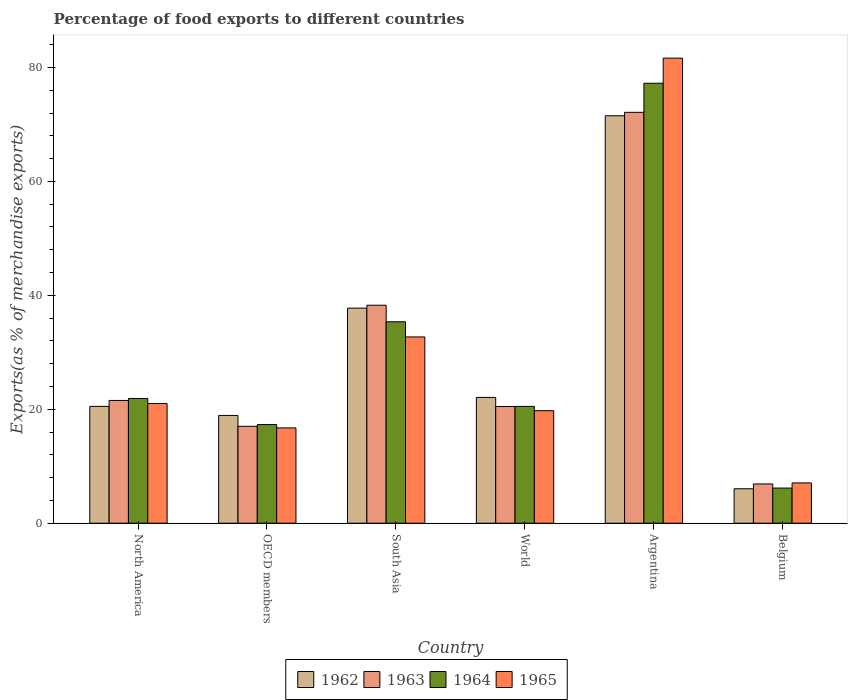How many different coloured bars are there?
Your response must be concise. 4. Are the number of bars on each tick of the X-axis equal?
Your response must be concise. Yes. What is the percentage of exports to different countries in 1963 in OECD members?
Your answer should be very brief. 17.01. Across all countries, what is the maximum percentage of exports to different countries in 1965?
Offer a terse response. 81.64. Across all countries, what is the minimum percentage of exports to different countries in 1962?
Provide a succinct answer. 6.04. What is the total percentage of exports to different countries in 1965 in the graph?
Your answer should be compact. 178.89. What is the difference between the percentage of exports to different countries in 1963 in North America and that in South Asia?
Give a very brief answer. -16.72. What is the difference between the percentage of exports to different countries in 1965 in Belgium and the percentage of exports to different countries in 1963 in South Asia?
Give a very brief answer. -31.19. What is the average percentage of exports to different countries in 1964 per country?
Provide a short and direct response. 29.75. What is the difference between the percentage of exports to different countries of/in 1962 and percentage of exports to different countries of/in 1964 in Argentina?
Provide a succinct answer. -5.71. What is the ratio of the percentage of exports to different countries in 1962 in Belgium to that in World?
Provide a succinct answer. 0.27. Is the percentage of exports to different countries in 1963 in Belgium less than that in South Asia?
Your response must be concise. Yes. What is the difference between the highest and the second highest percentage of exports to different countries in 1964?
Offer a terse response. -13.46. What is the difference between the highest and the lowest percentage of exports to different countries in 1962?
Your answer should be compact. 65.47. What does the 4th bar from the left in Argentina represents?
Offer a very short reply. 1965. What does the 4th bar from the right in South Asia represents?
Provide a short and direct response. 1962. How many bars are there?
Keep it short and to the point. 24. What is the difference between two consecutive major ticks on the Y-axis?
Give a very brief answer. 20. Are the values on the major ticks of Y-axis written in scientific E-notation?
Ensure brevity in your answer.  No. Where does the legend appear in the graph?
Ensure brevity in your answer.  Bottom center. How many legend labels are there?
Your response must be concise. 4. How are the legend labels stacked?
Your answer should be compact. Horizontal. What is the title of the graph?
Your answer should be compact. Percentage of food exports to different countries. What is the label or title of the X-axis?
Ensure brevity in your answer.  Country. What is the label or title of the Y-axis?
Provide a short and direct response. Exports(as % of merchandise exports). What is the Exports(as % of merchandise exports) of 1962 in North America?
Keep it short and to the point. 20.51. What is the Exports(as % of merchandise exports) in 1963 in North America?
Ensure brevity in your answer.  21.55. What is the Exports(as % of merchandise exports) in 1964 in North America?
Offer a terse response. 21.9. What is the Exports(as % of merchandise exports) in 1965 in North America?
Keep it short and to the point. 21.01. What is the Exports(as % of merchandise exports) of 1962 in OECD members?
Offer a terse response. 18.92. What is the Exports(as % of merchandise exports) in 1963 in OECD members?
Ensure brevity in your answer.  17.01. What is the Exports(as % of merchandise exports) of 1964 in OECD members?
Provide a succinct answer. 17.31. What is the Exports(as % of merchandise exports) of 1965 in OECD members?
Keep it short and to the point. 16.73. What is the Exports(as % of merchandise exports) of 1962 in South Asia?
Provide a succinct answer. 37.75. What is the Exports(as % of merchandise exports) in 1963 in South Asia?
Ensure brevity in your answer.  38.26. What is the Exports(as % of merchandise exports) in 1964 in South Asia?
Give a very brief answer. 35.36. What is the Exports(as % of merchandise exports) of 1965 in South Asia?
Give a very brief answer. 32.7. What is the Exports(as % of merchandise exports) of 1962 in World?
Give a very brief answer. 22.08. What is the Exports(as % of merchandise exports) of 1963 in World?
Make the answer very short. 20.49. What is the Exports(as % of merchandise exports) in 1964 in World?
Offer a terse response. 20.5. What is the Exports(as % of merchandise exports) of 1965 in World?
Offer a very short reply. 19.75. What is the Exports(as % of merchandise exports) in 1962 in Argentina?
Offer a terse response. 71.52. What is the Exports(as % of merchandise exports) in 1963 in Argentina?
Keep it short and to the point. 72.12. What is the Exports(as % of merchandise exports) in 1964 in Argentina?
Provide a short and direct response. 77.23. What is the Exports(as % of merchandise exports) in 1965 in Argentina?
Your response must be concise. 81.64. What is the Exports(as % of merchandise exports) in 1962 in Belgium?
Your response must be concise. 6.04. What is the Exports(as % of merchandise exports) in 1963 in Belgium?
Provide a short and direct response. 6.89. What is the Exports(as % of merchandise exports) of 1964 in Belgium?
Provide a short and direct response. 6.17. What is the Exports(as % of merchandise exports) of 1965 in Belgium?
Give a very brief answer. 7.07. Across all countries, what is the maximum Exports(as % of merchandise exports) in 1962?
Offer a very short reply. 71.52. Across all countries, what is the maximum Exports(as % of merchandise exports) of 1963?
Give a very brief answer. 72.12. Across all countries, what is the maximum Exports(as % of merchandise exports) of 1964?
Keep it short and to the point. 77.23. Across all countries, what is the maximum Exports(as % of merchandise exports) in 1965?
Offer a terse response. 81.64. Across all countries, what is the minimum Exports(as % of merchandise exports) in 1962?
Give a very brief answer. 6.04. Across all countries, what is the minimum Exports(as % of merchandise exports) in 1963?
Give a very brief answer. 6.89. Across all countries, what is the minimum Exports(as % of merchandise exports) in 1964?
Keep it short and to the point. 6.17. Across all countries, what is the minimum Exports(as % of merchandise exports) of 1965?
Keep it short and to the point. 7.07. What is the total Exports(as % of merchandise exports) in 1962 in the graph?
Your answer should be compact. 176.82. What is the total Exports(as % of merchandise exports) of 1963 in the graph?
Make the answer very short. 176.32. What is the total Exports(as % of merchandise exports) in 1964 in the graph?
Make the answer very short. 178.47. What is the total Exports(as % of merchandise exports) in 1965 in the graph?
Make the answer very short. 178.89. What is the difference between the Exports(as % of merchandise exports) in 1962 in North America and that in OECD members?
Make the answer very short. 1.59. What is the difference between the Exports(as % of merchandise exports) in 1963 in North America and that in OECD members?
Your answer should be compact. 4.54. What is the difference between the Exports(as % of merchandise exports) in 1964 in North America and that in OECD members?
Offer a very short reply. 4.58. What is the difference between the Exports(as % of merchandise exports) of 1965 in North America and that in OECD members?
Your answer should be compact. 4.28. What is the difference between the Exports(as % of merchandise exports) in 1962 in North America and that in South Asia?
Make the answer very short. -17.25. What is the difference between the Exports(as % of merchandise exports) in 1963 in North America and that in South Asia?
Keep it short and to the point. -16.72. What is the difference between the Exports(as % of merchandise exports) of 1964 in North America and that in South Asia?
Your answer should be compact. -13.46. What is the difference between the Exports(as % of merchandise exports) in 1965 in North America and that in South Asia?
Provide a succinct answer. -11.69. What is the difference between the Exports(as % of merchandise exports) of 1962 in North America and that in World?
Provide a succinct answer. -1.57. What is the difference between the Exports(as % of merchandise exports) in 1963 in North America and that in World?
Ensure brevity in your answer.  1.06. What is the difference between the Exports(as % of merchandise exports) in 1964 in North America and that in World?
Provide a short and direct response. 1.39. What is the difference between the Exports(as % of merchandise exports) in 1965 in North America and that in World?
Your answer should be compact. 1.26. What is the difference between the Exports(as % of merchandise exports) of 1962 in North America and that in Argentina?
Give a very brief answer. -51.01. What is the difference between the Exports(as % of merchandise exports) of 1963 in North America and that in Argentina?
Ensure brevity in your answer.  -50.58. What is the difference between the Exports(as % of merchandise exports) in 1964 in North America and that in Argentina?
Provide a short and direct response. -55.33. What is the difference between the Exports(as % of merchandise exports) of 1965 in North America and that in Argentina?
Keep it short and to the point. -60.63. What is the difference between the Exports(as % of merchandise exports) of 1962 in North America and that in Belgium?
Keep it short and to the point. 14.47. What is the difference between the Exports(as % of merchandise exports) of 1963 in North America and that in Belgium?
Make the answer very short. 14.66. What is the difference between the Exports(as % of merchandise exports) of 1964 in North America and that in Belgium?
Your response must be concise. 15.73. What is the difference between the Exports(as % of merchandise exports) in 1965 in North America and that in Belgium?
Your answer should be compact. 13.93. What is the difference between the Exports(as % of merchandise exports) of 1962 in OECD members and that in South Asia?
Keep it short and to the point. -18.84. What is the difference between the Exports(as % of merchandise exports) in 1963 in OECD members and that in South Asia?
Give a very brief answer. -21.26. What is the difference between the Exports(as % of merchandise exports) of 1964 in OECD members and that in South Asia?
Your response must be concise. -18.05. What is the difference between the Exports(as % of merchandise exports) of 1965 in OECD members and that in South Asia?
Provide a succinct answer. -15.97. What is the difference between the Exports(as % of merchandise exports) in 1962 in OECD members and that in World?
Your response must be concise. -3.16. What is the difference between the Exports(as % of merchandise exports) of 1963 in OECD members and that in World?
Make the answer very short. -3.48. What is the difference between the Exports(as % of merchandise exports) in 1964 in OECD members and that in World?
Make the answer very short. -3.19. What is the difference between the Exports(as % of merchandise exports) of 1965 in OECD members and that in World?
Offer a very short reply. -3.02. What is the difference between the Exports(as % of merchandise exports) in 1962 in OECD members and that in Argentina?
Your answer should be very brief. -52.6. What is the difference between the Exports(as % of merchandise exports) of 1963 in OECD members and that in Argentina?
Offer a terse response. -55.12. What is the difference between the Exports(as % of merchandise exports) of 1964 in OECD members and that in Argentina?
Your response must be concise. -59.91. What is the difference between the Exports(as % of merchandise exports) in 1965 in OECD members and that in Argentina?
Keep it short and to the point. -64.91. What is the difference between the Exports(as % of merchandise exports) of 1962 in OECD members and that in Belgium?
Provide a succinct answer. 12.87. What is the difference between the Exports(as % of merchandise exports) of 1963 in OECD members and that in Belgium?
Keep it short and to the point. 10.12. What is the difference between the Exports(as % of merchandise exports) of 1964 in OECD members and that in Belgium?
Offer a very short reply. 11.14. What is the difference between the Exports(as % of merchandise exports) in 1965 in OECD members and that in Belgium?
Provide a succinct answer. 9.66. What is the difference between the Exports(as % of merchandise exports) in 1962 in South Asia and that in World?
Make the answer very short. 15.67. What is the difference between the Exports(as % of merchandise exports) of 1963 in South Asia and that in World?
Your answer should be compact. 17.78. What is the difference between the Exports(as % of merchandise exports) of 1964 in South Asia and that in World?
Provide a short and direct response. 14.86. What is the difference between the Exports(as % of merchandise exports) in 1965 in South Asia and that in World?
Your response must be concise. 12.95. What is the difference between the Exports(as % of merchandise exports) of 1962 in South Asia and that in Argentina?
Your answer should be compact. -33.76. What is the difference between the Exports(as % of merchandise exports) in 1963 in South Asia and that in Argentina?
Your response must be concise. -33.86. What is the difference between the Exports(as % of merchandise exports) in 1964 in South Asia and that in Argentina?
Keep it short and to the point. -41.87. What is the difference between the Exports(as % of merchandise exports) in 1965 in South Asia and that in Argentina?
Make the answer very short. -48.94. What is the difference between the Exports(as % of merchandise exports) in 1962 in South Asia and that in Belgium?
Offer a terse response. 31.71. What is the difference between the Exports(as % of merchandise exports) of 1963 in South Asia and that in Belgium?
Keep it short and to the point. 31.37. What is the difference between the Exports(as % of merchandise exports) of 1964 in South Asia and that in Belgium?
Provide a short and direct response. 29.19. What is the difference between the Exports(as % of merchandise exports) in 1965 in South Asia and that in Belgium?
Your answer should be compact. 25.62. What is the difference between the Exports(as % of merchandise exports) of 1962 in World and that in Argentina?
Ensure brevity in your answer.  -49.44. What is the difference between the Exports(as % of merchandise exports) of 1963 in World and that in Argentina?
Give a very brief answer. -51.64. What is the difference between the Exports(as % of merchandise exports) of 1964 in World and that in Argentina?
Offer a very short reply. -56.72. What is the difference between the Exports(as % of merchandise exports) in 1965 in World and that in Argentina?
Offer a very short reply. -61.88. What is the difference between the Exports(as % of merchandise exports) of 1962 in World and that in Belgium?
Provide a short and direct response. 16.04. What is the difference between the Exports(as % of merchandise exports) of 1963 in World and that in Belgium?
Give a very brief answer. 13.6. What is the difference between the Exports(as % of merchandise exports) of 1964 in World and that in Belgium?
Provide a succinct answer. 14.33. What is the difference between the Exports(as % of merchandise exports) in 1965 in World and that in Belgium?
Provide a short and direct response. 12.68. What is the difference between the Exports(as % of merchandise exports) in 1962 in Argentina and that in Belgium?
Your response must be concise. 65.47. What is the difference between the Exports(as % of merchandise exports) of 1963 in Argentina and that in Belgium?
Provide a short and direct response. 65.23. What is the difference between the Exports(as % of merchandise exports) in 1964 in Argentina and that in Belgium?
Offer a terse response. 71.06. What is the difference between the Exports(as % of merchandise exports) in 1965 in Argentina and that in Belgium?
Give a very brief answer. 74.56. What is the difference between the Exports(as % of merchandise exports) of 1962 in North America and the Exports(as % of merchandise exports) of 1963 in OECD members?
Your answer should be very brief. 3.5. What is the difference between the Exports(as % of merchandise exports) of 1962 in North America and the Exports(as % of merchandise exports) of 1964 in OECD members?
Ensure brevity in your answer.  3.19. What is the difference between the Exports(as % of merchandise exports) of 1962 in North America and the Exports(as % of merchandise exports) of 1965 in OECD members?
Keep it short and to the point. 3.78. What is the difference between the Exports(as % of merchandise exports) of 1963 in North America and the Exports(as % of merchandise exports) of 1964 in OECD members?
Provide a succinct answer. 4.23. What is the difference between the Exports(as % of merchandise exports) of 1963 in North America and the Exports(as % of merchandise exports) of 1965 in OECD members?
Provide a succinct answer. 4.82. What is the difference between the Exports(as % of merchandise exports) in 1964 in North America and the Exports(as % of merchandise exports) in 1965 in OECD members?
Provide a succinct answer. 5.17. What is the difference between the Exports(as % of merchandise exports) of 1962 in North America and the Exports(as % of merchandise exports) of 1963 in South Asia?
Your answer should be compact. -17.76. What is the difference between the Exports(as % of merchandise exports) in 1962 in North America and the Exports(as % of merchandise exports) in 1964 in South Asia?
Provide a short and direct response. -14.85. What is the difference between the Exports(as % of merchandise exports) of 1962 in North America and the Exports(as % of merchandise exports) of 1965 in South Asia?
Offer a terse response. -12.19. What is the difference between the Exports(as % of merchandise exports) in 1963 in North America and the Exports(as % of merchandise exports) in 1964 in South Asia?
Offer a terse response. -13.81. What is the difference between the Exports(as % of merchandise exports) in 1963 in North America and the Exports(as % of merchandise exports) in 1965 in South Asia?
Your answer should be very brief. -11.15. What is the difference between the Exports(as % of merchandise exports) of 1964 in North America and the Exports(as % of merchandise exports) of 1965 in South Asia?
Give a very brief answer. -10.8. What is the difference between the Exports(as % of merchandise exports) of 1962 in North America and the Exports(as % of merchandise exports) of 1963 in World?
Offer a very short reply. 0.02. What is the difference between the Exports(as % of merchandise exports) in 1962 in North America and the Exports(as % of merchandise exports) in 1964 in World?
Offer a terse response. 0.01. What is the difference between the Exports(as % of merchandise exports) in 1962 in North America and the Exports(as % of merchandise exports) in 1965 in World?
Your answer should be very brief. 0.76. What is the difference between the Exports(as % of merchandise exports) in 1963 in North America and the Exports(as % of merchandise exports) in 1964 in World?
Offer a very short reply. 1.04. What is the difference between the Exports(as % of merchandise exports) in 1963 in North America and the Exports(as % of merchandise exports) in 1965 in World?
Keep it short and to the point. 1.8. What is the difference between the Exports(as % of merchandise exports) in 1964 in North America and the Exports(as % of merchandise exports) in 1965 in World?
Make the answer very short. 2.15. What is the difference between the Exports(as % of merchandise exports) in 1962 in North America and the Exports(as % of merchandise exports) in 1963 in Argentina?
Give a very brief answer. -51.62. What is the difference between the Exports(as % of merchandise exports) in 1962 in North America and the Exports(as % of merchandise exports) in 1964 in Argentina?
Your answer should be compact. -56.72. What is the difference between the Exports(as % of merchandise exports) in 1962 in North America and the Exports(as % of merchandise exports) in 1965 in Argentina?
Provide a succinct answer. -61.13. What is the difference between the Exports(as % of merchandise exports) in 1963 in North America and the Exports(as % of merchandise exports) in 1964 in Argentina?
Offer a terse response. -55.68. What is the difference between the Exports(as % of merchandise exports) of 1963 in North America and the Exports(as % of merchandise exports) of 1965 in Argentina?
Make the answer very short. -60.09. What is the difference between the Exports(as % of merchandise exports) in 1964 in North America and the Exports(as % of merchandise exports) in 1965 in Argentina?
Your answer should be very brief. -59.74. What is the difference between the Exports(as % of merchandise exports) in 1962 in North America and the Exports(as % of merchandise exports) in 1963 in Belgium?
Keep it short and to the point. 13.62. What is the difference between the Exports(as % of merchandise exports) of 1962 in North America and the Exports(as % of merchandise exports) of 1964 in Belgium?
Your answer should be compact. 14.34. What is the difference between the Exports(as % of merchandise exports) of 1962 in North America and the Exports(as % of merchandise exports) of 1965 in Belgium?
Your answer should be compact. 13.44. What is the difference between the Exports(as % of merchandise exports) in 1963 in North America and the Exports(as % of merchandise exports) in 1964 in Belgium?
Provide a succinct answer. 15.38. What is the difference between the Exports(as % of merchandise exports) in 1963 in North America and the Exports(as % of merchandise exports) in 1965 in Belgium?
Provide a short and direct response. 14.48. What is the difference between the Exports(as % of merchandise exports) of 1964 in North America and the Exports(as % of merchandise exports) of 1965 in Belgium?
Your response must be concise. 14.82. What is the difference between the Exports(as % of merchandise exports) of 1962 in OECD members and the Exports(as % of merchandise exports) of 1963 in South Asia?
Ensure brevity in your answer.  -19.35. What is the difference between the Exports(as % of merchandise exports) of 1962 in OECD members and the Exports(as % of merchandise exports) of 1964 in South Asia?
Your response must be concise. -16.44. What is the difference between the Exports(as % of merchandise exports) in 1962 in OECD members and the Exports(as % of merchandise exports) in 1965 in South Asia?
Ensure brevity in your answer.  -13.78. What is the difference between the Exports(as % of merchandise exports) in 1963 in OECD members and the Exports(as % of merchandise exports) in 1964 in South Asia?
Provide a short and direct response. -18.35. What is the difference between the Exports(as % of merchandise exports) of 1963 in OECD members and the Exports(as % of merchandise exports) of 1965 in South Asia?
Your answer should be compact. -15.69. What is the difference between the Exports(as % of merchandise exports) of 1964 in OECD members and the Exports(as % of merchandise exports) of 1965 in South Asia?
Ensure brevity in your answer.  -15.38. What is the difference between the Exports(as % of merchandise exports) in 1962 in OECD members and the Exports(as % of merchandise exports) in 1963 in World?
Provide a short and direct response. -1.57. What is the difference between the Exports(as % of merchandise exports) in 1962 in OECD members and the Exports(as % of merchandise exports) in 1964 in World?
Your answer should be compact. -1.59. What is the difference between the Exports(as % of merchandise exports) in 1962 in OECD members and the Exports(as % of merchandise exports) in 1965 in World?
Ensure brevity in your answer.  -0.83. What is the difference between the Exports(as % of merchandise exports) of 1963 in OECD members and the Exports(as % of merchandise exports) of 1964 in World?
Provide a succinct answer. -3.5. What is the difference between the Exports(as % of merchandise exports) in 1963 in OECD members and the Exports(as % of merchandise exports) in 1965 in World?
Your answer should be compact. -2.74. What is the difference between the Exports(as % of merchandise exports) of 1964 in OECD members and the Exports(as % of merchandise exports) of 1965 in World?
Give a very brief answer. -2.44. What is the difference between the Exports(as % of merchandise exports) of 1962 in OECD members and the Exports(as % of merchandise exports) of 1963 in Argentina?
Provide a succinct answer. -53.21. What is the difference between the Exports(as % of merchandise exports) in 1962 in OECD members and the Exports(as % of merchandise exports) in 1964 in Argentina?
Your answer should be very brief. -58.31. What is the difference between the Exports(as % of merchandise exports) of 1962 in OECD members and the Exports(as % of merchandise exports) of 1965 in Argentina?
Offer a very short reply. -62.72. What is the difference between the Exports(as % of merchandise exports) of 1963 in OECD members and the Exports(as % of merchandise exports) of 1964 in Argentina?
Your answer should be very brief. -60.22. What is the difference between the Exports(as % of merchandise exports) of 1963 in OECD members and the Exports(as % of merchandise exports) of 1965 in Argentina?
Give a very brief answer. -64.63. What is the difference between the Exports(as % of merchandise exports) in 1964 in OECD members and the Exports(as % of merchandise exports) in 1965 in Argentina?
Provide a short and direct response. -64.32. What is the difference between the Exports(as % of merchandise exports) of 1962 in OECD members and the Exports(as % of merchandise exports) of 1963 in Belgium?
Provide a short and direct response. 12.03. What is the difference between the Exports(as % of merchandise exports) of 1962 in OECD members and the Exports(as % of merchandise exports) of 1964 in Belgium?
Offer a very short reply. 12.75. What is the difference between the Exports(as % of merchandise exports) of 1962 in OECD members and the Exports(as % of merchandise exports) of 1965 in Belgium?
Ensure brevity in your answer.  11.84. What is the difference between the Exports(as % of merchandise exports) of 1963 in OECD members and the Exports(as % of merchandise exports) of 1964 in Belgium?
Offer a very short reply. 10.84. What is the difference between the Exports(as % of merchandise exports) of 1963 in OECD members and the Exports(as % of merchandise exports) of 1965 in Belgium?
Ensure brevity in your answer.  9.93. What is the difference between the Exports(as % of merchandise exports) in 1964 in OECD members and the Exports(as % of merchandise exports) in 1965 in Belgium?
Make the answer very short. 10.24. What is the difference between the Exports(as % of merchandise exports) in 1962 in South Asia and the Exports(as % of merchandise exports) in 1963 in World?
Offer a very short reply. 17.27. What is the difference between the Exports(as % of merchandise exports) of 1962 in South Asia and the Exports(as % of merchandise exports) of 1964 in World?
Ensure brevity in your answer.  17.25. What is the difference between the Exports(as % of merchandise exports) of 1962 in South Asia and the Exports(as % of merchandise exports) of 1965 in World?
Make the answer very short. 18. What is the difference between the Exports(as % of merchandise exports) in 1963 in South Asia and the Exports(as % of merchandise exports) in 1964 in World?
Ensure brevity in your answer.  17.76. What is the difference between the Exports(as % of merchandise exports) of 1963 in South Asia and the Exports(as % of merchandise exports) of 1965 in World?
Offer a terse response. 18.51. What is the difference between the Exports(as % of merchandise exports) in 1964 in South Asia and the Exports(as % of merchandise exports) in 1965 in World?
Keep it short and to the point. 15.61. What is the difference between the Exports(as % of merchandise exports) of 1962 in South Asia and the Exports(as % of merchandise exports) of 1963 in Argentina?
Provide a succinct answer. -34.37. What is the difference between the Exports(as % of merchandise exports) of 1962 in South Asia and the Exports(as % of merchandise exports) of 1964 in Argentina?
Ensure brevity in your answer.  -39.47. What is the difference between the Exports(as % of merchandise exports) of 1962 in South Asia and the Exports(as % of merchandise exports) of 1965 in Argentina?
Provide a succinct answer. -43.88. What is the difference between the Exports(as % of merchandise exports) in 1963 in South Asia and the Exports(as % of merchandise exports) in 1964 in Argentina?
Offer a very short reply. -38.96. What is the difference between the Exports(as % of merchandise exports) in 1963 in South Asia and the Exports(as % of merchandise exports) in 1965 in Argentina?
Keep it short and to the point. -43.37. What is the difference between the Exports(as % of merchandise exports) in 1964 in South Asia and the Exports(as % of merchandise exports) in 1965 in Argentina?
Offer a very short reply. -46.28. What is the difference between the Exports(as % of merchandise exports) in 1962 in South Asia and the Exports(as % of merchandise exports) in 1963 in Belgium?
Your response must be concise. 30.86. What is the difference between the Exports(as % of merchandise exports) in 1962 in South Asia and the Exports(as % of merchandise exports) in 1964 in Belgium?
Offer a terse response. 31.58. What is the difference between the Exports(as % of merchandise exports) in 1962 in South Asia and the Exports(as % of merchandise exports) in 1965 in Belgium?
Your response must be concise. 30.68. What is the difference between the Exports(as % of merchandise exports) of 1963 in South Asia and the Exports(as % of merchandise exports) of 1964 in Belgium?
Provide a short and direct response. 32.09. What is the difference between the Exports(as % of merchandise exports) of 1963 in South Asia and the Exports(as % of merchandise exports) of 1965 in Belgium?
Provide a succinct answer. 31.19. What is the difference between the Exports(as % of merchandise exports) of 1964 in South Asia and the Exports(as % of merchandise exports) of 1965 in Belgium?
Ensure brevity in your answer.  28.29. What is the difference between the Exports(as % of merchandise exports) in 1962 in World and the Exports(as % of merchandise exports) in 1963 in Argentina?
Make the answer very short. -50.04. What is the difference between the Exports(as % of merchandise exports) in 1962 in World and the Exports(as % of merchandise exports) in 1964 in Argentina?
Give a very brief answer. -55.15. What is the difference between the Exports(as % of merchandise exports) of 1962 in World and the Exports(as % of merchandise exports) of 1965 in Argentina?
Keep it short and to the point. -59.55. What is the difference between the Exports(as % of merchandise exports) of 1963 in World and the Exports(as % of merchandise exports) of 1964 in Argentina?
Your answer should be very brief. -56.74. What is the difference between the Exports(as % of merchandise exports) in 1963 in World and the Exports(as % of merchandise exports) in 1965 in Argentina?
Provide a succinct answer. -61.15. What is the difference between the Exports(as % of merchandise exports) in 1964 in World and the Exports(as % of merchandise exports) in 1965 in Argentina?
Keep it short and to the point. -61.13. What is the difference between the Exports(as % of merchandise exports) in 1962 in World and the Exports(as % of merchandise exports) in 1963 in Belgium?
Ensure brevity in your answer.  15.19. What is the difference between the Exports(as % of merchandise exports) of 1962 in World and the Exports(as % of merchandise exports) of 1964 in Belgium?
Offer a terse response. 15.91. What is the difference between the Exports(as % of merchandise exports) of 1962 in World and the Exports(as % of merchandise exports) of 1965 in Belgium?
Give a very brief answer. 15.01. What is the difference between the Exports(as % of merchandise exports) of 1963 in World and the Exports(as % of merchandise exports) of 1964 in Belgium?
Your answer should be compact. 14.32. What is the difference between the Exports(as % of merchandise exports) of 1963 in World and the Exports(as % of merchandise exports) of 1965 in Belgium?
Keep it short and to the point. 13.41. What is the difference between the Exports(as % of merchandise exports) in 1964 in World and the Exports(as % of merchandise exports) in 1965 in Belgium?
Make the answer very short. 13.43. What is the difference between the Exports(as % of merchandise exports) in 1962 in Argentina and the Exports(as % of merchandise exports) in 1963 in Belgium?
Offer a very short reply. 64.63. What is the difference between the Exports(as % of merchandise exports) of 1962 in Argentina and the Exports(as % of merchandise exports) of 1964 in Belgium?
Ensure brevity in your answer.  65.35. What is the difference between the Exports(as % of merchandise exports) in 1962 in Argentina and the Exports(as % of merchandise exports) in 1965 in Belgium?
Your answer should be very brief. 64.44. What is the difference between the Exports(as % of merchandise exports) in 1963 in Argentina and the Exports(as % of merchandise exports) in 1964 in Belgium?
Offer a very short reply. 65.95. What is the difference between the Exports(as % of merchandise exports) of 1963 in Argentina and the Exports(as % of merchandise exports) of 1965 in Belgium?
Offer a very short reply. 65.05. What is the difference between the Exports(as % of merchandise exports) of 1964 in Argentina and the Exports(as % of merchandise exports) of 1965 in Belgium?
Give a very brief answer. 70.15. What is the average Exports(as % of merchandise exports) of 1962 per country?
Give a very brief answer. 29.47. What is the average Exports(as % of merchandise exports) in 1963 per country?
Your response must be concise. 29.39. What is the average Exports(as % of merchandise exports) of 1964 per country?
Provide a short and direct response. 29.75. What is the average Exports(as % of merchandise exports) in 1965 per country?
Offer a very short reply. 29.82. What is the difference between the Exports(as % of merchandise exports) of 1962 and Exports(as % of merchandise exports) of 1963 in North America?
Provide a short and direct response. -1.04. What is the difference between the Exports(as % of merchandise exports) of 1962 and Exports(as % of merchandise exports) of 1964 in North America?
Your answer should be compact. -1.39. What is the difference between the Exports(as % of merchandise exports) in 1962 and Exports(as % of merchandise exports) in 1965 in North America?
Provide a succinct answer. -0.5. What is the difference between the Exports(as % of merchandise exports) in 1963 and Exports(as % of merchandise exports) in 1964 in North America?
Offer a terse response. -0.35. What is the difference between the Exports(as % of merchandise exports) of 1963 and Exports(as % of merchandise exports) of 1965 in North America?
Provide a short and direct response. 0.54. What is the difference between the Exports(as % of merchandise exports) in 1964 and Exports(as % of merchandise exports) in 1965 in North America?
Ensure brevity in your answer.  0.89. What is the difference between the Exports(as % of merchandise exports) in 1962 and Exports(as % of merchandise exports) in 1963 in OECD members?
Make the answer very short. 1.91. What is the difference between the Exports(as % of merchandise exports) of 1962 and Exports(as % of merchandise exports) of 1964 in OECD members?
Give a very brief answer. 1.6. What is the difference between the Exports(as % of merchandise exports) of 1962 and Exports(as % of merchandise exports) of 1965 in OECD members?
Provide a short and direct response. 2.19. What is the difference between the Exports(as % of merchandise exports) of 1963 and Exports(as % of merchandise exports) of 1964 in OECD members?
Offer a terse response. -0.31. What is the difference between the Exports(as % of merchandise exports) in 1963 and Exports(as % of merchandise exports) in 1965 in OECD members?
Your answer should be very brief. 0.28. What is the difference between the Exports(as % of merchandise exports) of 1964 and Exports(as % of merchandise exports) of 1965 in OECD members?
Give a very brief answer. 0.59. What is the difference between the Exports(as % of merchandise exports) in 1962 and Exports(as % of merchandise exports) in 1963 in South Asia?
Make the answer very short. -0.51. What is the difference between the Exports(as % of merchandise exports) in 1962 and Exports(as % of merchandise exports) in 1964 in South Asia?
Give a very brief answer. 2.39. What is the difference between the Exports(as % of merchandise exports) of 1962 and Exports(as % of merchandise exports) of 1965 in South Asia?
Your answer should be compact. 5.06. What is the difference between the Exports(as % of merchandise exports) of 1963 and Exports(as % of merchandise exports) of 1964 in South Asia?
Provide a succinct answer. 2.9. What is the difference between the Exports(as % of merchandise exports) of 1963 and Exports(as % of merchandise exports) of 1965 in South Asia?
Make the answer very short. 5.57. What is the difference between the Exports(as % of merchandise exports) in 1964 and Exports(as % of merchandise exports) in 1965 in South Asia?
Offer a very short reply. 2.66. What is the difference between the Exports(as % of merchandise exports) in 1962 and Exports(as % of merchandise exports) in 1963 in World?
Provide a succinct answer. 1.59. What is the difference between the Exports(as % of merchandise exports) of 1962 and Exports(as % of merchandise exports) of 1964 in World?
Give a very brief answer. 1.58. What is the difference between the Exports(as % of merchandise exports) in 1962 and Exports(as % of merchandise exports) in 1965 in World?
Offer a very short reply. 2.33. What is the difference between the Exports(as % of merchandise exports) in 1963 and Exports(as % of merchandise exports) in 1964 in World?
Your answer should be very brief. -0.02. What is the difference between the Exports(as % of merchandise exports) of 1963 and Exports(as % of merchandise exports) of 1965 in World?
Your response must be concise. 0.74. What is the difference between the Exports(as % of merchandise exports) of 1964 and Exports(as % of merchandise exports) of 1965 in World?
Offer a very short reply. 0.75. What is the difference between the Exports(as % of merchandise exports) in 1962 and Exports(as % of merchandise exports) in 1963 in Argentina?
Make the answer very short. -0.61. What is the difference between the Exports(as % of merchandise exports) in 1962 and Exports(as % of merchandise exports) in 1964 in Argentina?
Your response must be concise. -5.71. What is the difference between the Exports(as % of merchandise exports) of 1962 and Exports(as % of merchandise exports) of 1965 in Argentina?
Keep it short and to the point. -10.12. What is the difference between the Exports(as % of merchandise exports) in 1963 and Exports(as % of merchandise exports) in 1964 in Argentina?
Your answer should be very brief. -5.1. What is the difference between the Exports(as % of merchandise exports) in 1963 and Exports(as % of merchandise exports) in 1965 in Argentina?
Offer a very short reply. -9.51. What is the difference between the Exports(as % of merchandise exports) of 1964 and Exports(as % of merchandise exports) of 1965 in Argentina?
Your response must be concise. -4.41. What is the difference between the Exports(as % of merchandise exports) of 1962 and Exports(as % of merchandise exports) of 1963 in Belgium?
Offer a very short reply. -0.85. What is the difference between the Exports(as % of merchandise exports) in 1962 and Exports(as % of merchandise exports) in 1964 in Belgium?
Provide a short and direct response. -0.13. What is the difference between the Exports(as % of merchandise exports) in 1962 and Exports(as % of merchandise exports) in 1965 in Belgium?
Give a very brief answer. -1.03. What is the difference between the Exports(as % of merchandise exports) of 1963 and Exports(as % of merchandise exports) of 1964 in Belgium?
Give a very brief answer. 0.72. What is the difference between the Exports(as % of merchandise exports) in 1963 and Exports(as % of merchandise exports) in 1965 in Belgium?
Keep it short and to the point. -0.18. What is the difference between the Exports(as % of merchandise exports) in 1964 and Exports(as % of merchandise exports) in 1965 in Belgium?
Ensure brevity in your answer.  -0.9. What is the ratio of the Exports(as % of merchandise exports) in 1962 in North America to that in OECD members?
Your response must be concise. 1.08. What is the ratio of the Exports(as % of merchandise exports) of 1963 in North America to that in OECD members?
Ensure brevity in your answer.  1.27. What is the ratio of the Exports(as % of merchandise exports) of 1964 in North America to that in OECD members?
Give a very brief answer. 1.26. What is the ratio of the Exports(as % of merchandise exports) in 1965 in North America to that in OECD members?
Your answer should be compact. 1.26. What is the ratio of the Exports(as % of merchandise exports) of 1962 in North America to that in South Asia?
Provide a short and direct response. 0.54. What is the ratio of the Exports(as % of merchandise exports) in 1963 in North America to that in South Asia?
Make the answer very short. 0.56. What is the ratio of the Exports(as % of merchandise exports) in 1964 in North America to that in South Asia?
Keep it short and to the point. 0.62. What is the ratio of the Exports(as % of merchandise exports) in 1965 in North America to that in South Asia?
Make the answer very short. 0.64. What is the ratio of the Exports(as % of merchandise exports) in 1962 in North America to that in World?
Offer a terse response. 0.93. What is the ratio of the Exports(as % of merchandise exports) of 1963 in North America to that in World?
Your answer should be compact. 1.05. What is the ratio of the Exports(as % of merchandise exports) in 1964 in North America to that in World?
Make the answer very short. 1.07. What is the ratio of the Exports(as % of merchandise exports) in 1965 in North America to that in World?
Keep it short and to the point. 1.06. What is the ratio of the Exports(as % of merchandise exports) of 1962 in North America to that in Argentina?
Your response must be concise. 0.29. What is the ratio of the Exports(as % of merchandise exports) in 1963 in North America to that in Argentina?
Give a very brief answer. 0.3. What is the ratio of the Exports(as % of merchandise exports) in 1964 in North America to that in Argentina?
Keep it short and to the point. 0.28. What is the ratio of the Exports(as % of merchandise exports) of 1965 in North America to that in Argentina?
Provide a succinct answer. 0.26. What is the ratio of the Exports(as % of merchandise exports) in 1962 in North America to that in Belgium?
Offer a terse response. 3.39. What is the ratio of the Exports(as % of merchandise exports) in 1963 in North America to that in Belgium?
Provide a short and direct response. 3.13. What is the ratio of the Exports(as % of merchandise exports) in 1964 in North America to that in Belgium?
Your answer should be compact. 3.55. What is the ratio of the Exports(as % of merchandise exports) in 1965 in North America to that in Belgium?
Your answer should be very brief. 2.97. What is the ratio of the Exports(as % of merchandise exports) of 1962 in OECD members to that in South Asia?
Your response must be concise. 0.5. What is the ratio of the Exports(as % of merchandise exports) in 1963 in OECD members to that in South Asia?
Make the answer very short. 0.44. What is the ratio of the Exports(as % of merchandise exports) of 1964 in OECD members to that in South Asia?
Your answer should be compact. 0.49. What is the ratio of the Exports(as % of merchandise exports) in 1965 in OECD members to that in South Asia?
Provide a succinct answer. 0.51. What is the ratio of the Exports(as % of merchandise exports) in 1962 in OECD members to that in World?
Offer a very short reply. 0.86. What is the ratio of the Exports(as % of merchandise exports) in 1963 in OECD members to that in World?
Give a very brief answer. 0.83. What is the ratio of the Exports(as % of merchandise exports) in 1964 in OECD members to that in World?
Provide a succinct answer. 0.84. What is the ratio of the Exports(as % of merchandise exports) of 1965 in OECD members to that in World?
Your answer should be very brief. 0.85. What is the ratio of the Exports(as % of merchandise exports) in 1962 in OECD members to that in Argentina?
Offer a very short reply. 0.26. What is the ratio of the Exports(as % of merchandise exports) in 1963 in OECD members to that in Argentina?
Give a very brief answer. 0.24. What is the ratio of the Exports(as % of merchandise exports) of 1964 in OECD members to that in Argentina?
Provide a short and direct response. 0.22. What is the ratio of the Exports(as % of merchandise exports) of 1965 in OECD members to that in Argentina?
Offer a terse response. 0.2. What is the ratio of the Exports(as % of merchandise exports) of 1962 in OECD members to that in Belgium?
Give a very brief answer. 3.13. What is the ratio of the Exports(as % of merchandise exports) of 1963 in OECD members to that in Belgium?
Give a very brief answer. 2.47. What is the ratio of the Exports(as % of merchandise exports) in 1964 in OECD members to that in Belgium?
Offer a terse response. 2.81. What is the ratio of the Exports(as % of merchandise exports) of 1965 in OECD members to that in Belgium?
Give a very brief answer. 2.37. What is the ratio of the Exports(as % of merchandise exports) in 1962 in South Asia to that in World?
Ensure brevity in your answer.  1.71. What is the ratio of the Exports(as % of merchandise exports) of 1963 in South Asia to that in World?
Keep it short and to the point. 1.87. What is the ratio of the Exports(as % of merchandise exports) of 1964 in South Asia to that in World?
Provide a succinct answer. 1.72. What is the ratio of the Exports(as % of merchandise exports) of 1965 in South Asia to that in World?
Offer a very short reply. 1.66. What is the ratio of the Exports(as % of merchandise exports) in 1962 in South Asia to that in Argentina?
Offer a terse response. 0.53. What is the ratio of the Exports(as % of merchandise exports) of 1963 in South Asia to that in Argentina?
Offer a very short reply. 0.53. What is the ratio of the Exports(as % of merchandise exports) of 1964 in South Asia to that in Argentina?
Keep it short and to the point. 0.46. What is the ratio of the Exports(as % of merchandise exports) in 1965 in South Asia to that in Argentina?
Provide a succinct answer. 0.4. What is the ratio of the Exports(as % of merchandise exports) in 1962 in South Asia to that in Belgium?
Offer a very short reply. 6.25. What is the ratio of the Exports(as % of merchandise exports) in 1963 in South Asia to that in Belgium?
Your answer should be compact. 5.55. What is the ratio of the Exports(as % of merchandise exports) in 1964 in South Asia to that in Belgium?
Provide a short and direct response. 5.73. What is the ratio of the Exports(as % of merchandise exports) in 1965 in South Asia to that in Belgium?
Offer a terse response. 4.62. What is the ratio of the Exports(as % of merchandise exports) of 1962 in World to that in Argentina?
Your answer should be compact. 0.31. What is the ratio of the Exports(as % of merchandise exports) in 1963 in World to that in Argentina?
Ensure brevity in your answer.  0.28. What is the ratio of the Exports(as % of merchandise exports) of 1964 in World to that in Argentina?
Your answer should be very brief. 0.27. What is the ratio of the Exports(as % of merchandise exports) in 1965 in World to that in Argentina?
Make the answer very short. 0.24. What is the ratio of the Exports(as % of merchandise exports) in 1962 in World to that in Belgium?
Your response must be concise. 3.65. What is the ratio of the Exports(as % of merchandise exports) in 1963 in World to that in Belgium?
Ensure brevity in your answer.  2.97. What is the ratio of the Exports(as % of merchandise exports) of 1964 in World to that in Belgium?
Offer a very short reply. 3.32. What is the ratio of the Exports(as % of merchandise exports) in 1965 in World to that in Belgium?
Your answer should be very brief. 2.79. What is the ratio of the Exports(as % of merchandise exports) of 1962 in Argentina to that in Belgium?
Give a very brief answer. 11.84. What is the ratio of the Exports(as % of merchandise exports) in 1963 in Argentina to that in Belgium?
Provide a short and direct response. 10.47. What is the ratio of the Exports(as % of merchandise exports) of 1964 in Argentina to that in Belgium?
Provide a short and direct response. 12.52. What is the ratio of the Exports(as % of merchandise exports) of 1965 in Argentina to that in Belgium?
Offer a very short reply. 11.54. What is the difference between the highest and the second highest Exports(as % of merchandise exports) of 1962?
Your answer should be very brief. 33.76. What is the difference between the highest and the second highest Exports(as % of merchandise exports) of 1963?
Provide a short and direct response. 33.86. What is the difference between the highest and the second highest Exports(as % of merchandise exports) of 1964?
Your answer should be very brief. 41.87. What is the difference between the highest and the second highest Exports(as % of merchandise exports) of 1965?
Provide a short and direct response. 48.94. What is the difference between the highest and the lowest Exports(as % of merchandise exports) of 1962?
Your response must be concise. 65.47. What is the difference between the highest and the lowest Exports(as % of merchandise exports) in 1963?
Give a very brief answer. 65.23. What is the difference between the highest and the lowest Exports(as % of merchandise exports) in 1964?
Ensure brevity in your answer.  71.06. What is the difference between the highest and the lowest Exports(as % of merchandise exports) of 1965?
Provide a succinct answer. 74.56. 